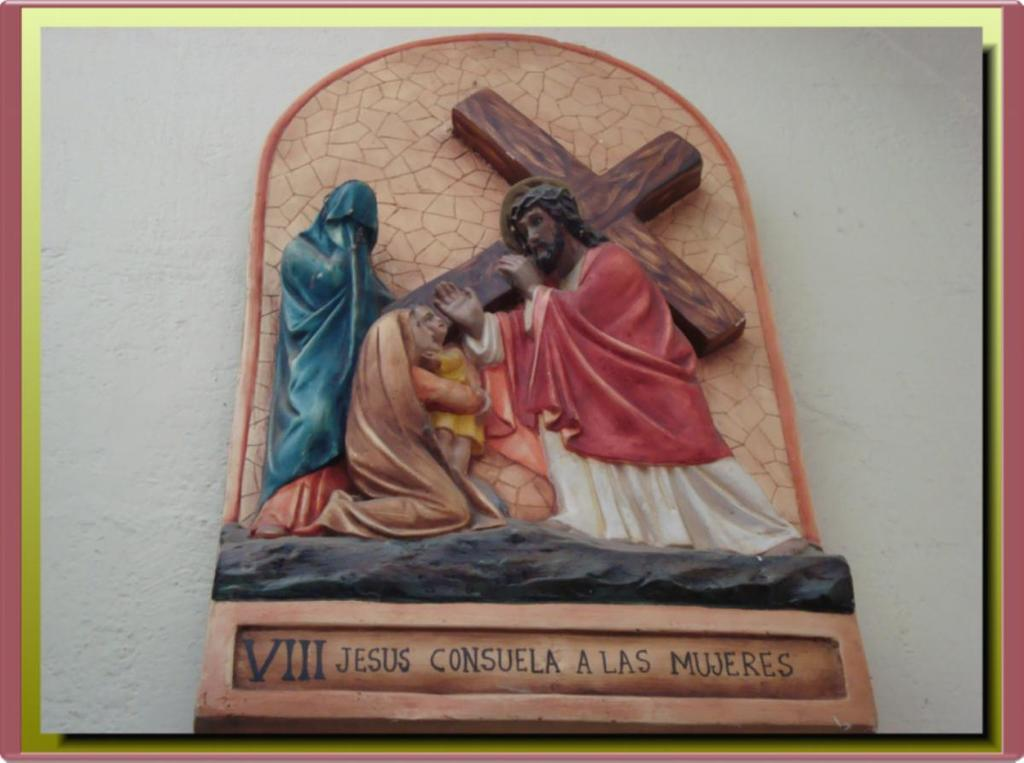<image>
Present a compact description of the photo's key features. A statue has the roman numeral VIII on the bottom. 